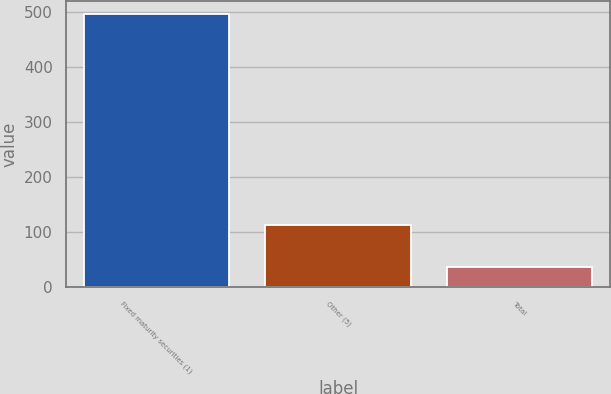Convert chart to OTSL. <chart><loc_0><loc_0><loc_500><loc_500><bar_chart><fcel>Fixed maturity securities (1)<fcel>Other (5)<fcel>Total<nl><fcel>496.3<fcel>112.7<fcel>36.1<nl></chart> 